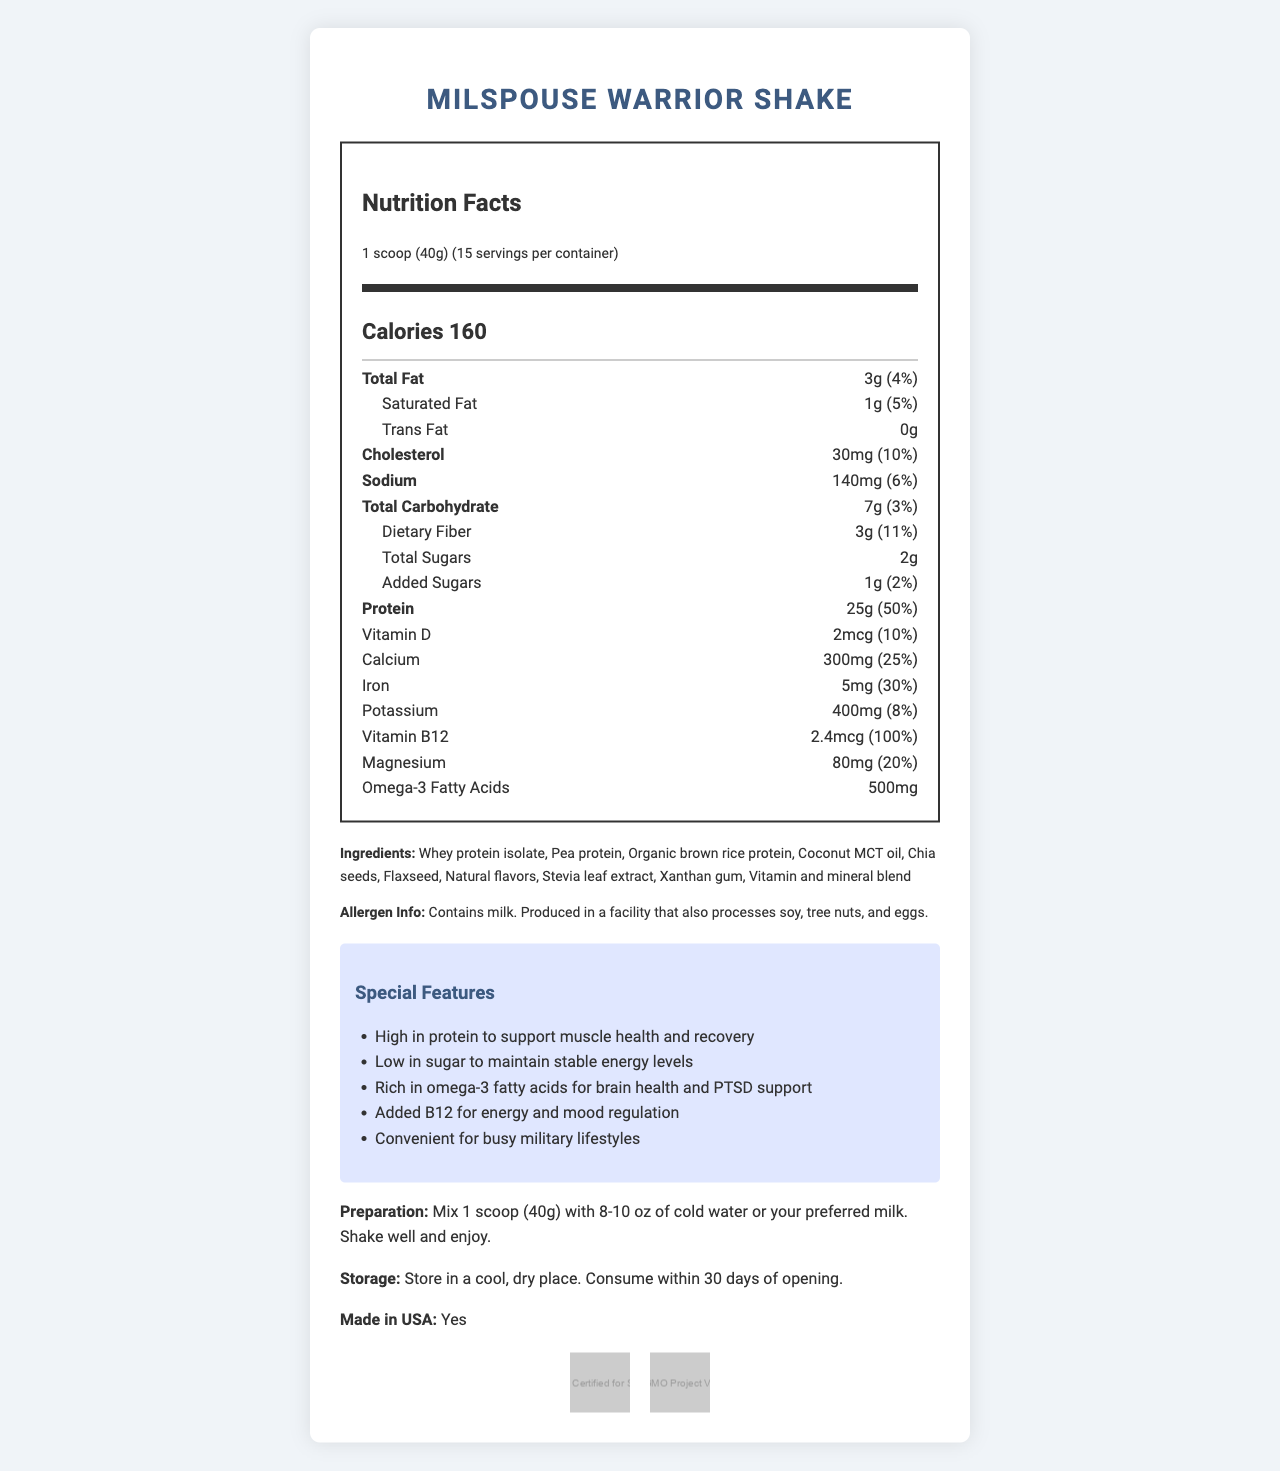what is the main source of protein in the MilSpouse Warrior Shake? The ingredients list indicates that "Whey protein isolate" is the first item, which means it is the main source of protein.
Answer: Whey protein isolate how many grams of total fat does each serving contain? The nutrition facts section of the document lists "Total Fat" as 3g per serving.
Answer: 3g what are the main features of the MilSpouse Warrior Shake? The document lists these features under the "Special Features" section.
Answer: High protein, Low sugar, Omega-3 fatty acids, Added B12, Convenience how many servings are there in one container? The document states "15 servings per container" in the nutrition facts section.
Answer: 15 what are the allergen warnings for this product? This information is explicitly stated under the "Allergen Info" section.
Answer: Contains milk. Produced in a facility that also processes soy, tree nuts, and eggs. how much vitamin D does each serving provide? The nutrition facts section shows that each serving provides 2mcg of vitamin D, which is 10% of the daily value.
Answer: 2mcg (10% DV) what is the amount of added sugars per serving? The nutrition facts indicate "Added Sugars" as 1g per serving.
Answer: 1g what are the certifications associated with the MilSpouse Warrior Shake? The document includes these certifications at the bottom of the page with visual icons.
Answer: NSF Certified for Sport, Non-GMO Project Verified which of the following is NOT an ingredient in the MilSpouse Warrior Shake? A. Chia seeds B. Coconut MCT oil C. Soy protein D. Stevia leaf extract The ingredients list does not include "Soy protein".
Answer: C. Soy protein what is the daily value percentage of protein per serving? A. 10% B. 20% C. 50% D. 100% The nutrition facts show that each serving provides 25g of protein, which is 50% of the daily value.
Answer: C. 50% is this product made in the USA? The document clearly states "Made in USA: Yes".
Answer: Yes describe the MilSpouse Warrior Shake nutrition facts and special features. The document provides detailed nutrition facts, including amounts of fat, cholesterol, carbohydrates, protein, and essential vitamins and minerals. It also lists several special features emphasizing the product's benefits for health and convenience.
Answer: The MilSpouse Warrior Shake is a meal replacement shake with high protein (25g per serving), low sugar (2g total sugars), various vitamins and minerals, and omega-3 fatty acids. It includes features such as protein for muscle recovery, low sugar for stable energy, omega-3 for brain health, added B12 for energy and mood regulation, and is convenient for busy military lifestyles. what is the recommended storage condition for this product? The storage instructions are clearly provided in the document.
Answer: Store in a cool, dry place. Consume within 30 days of opening. does the document mention the price of the MilSpouse Warrior Shake? The document includes detailed information about the nutrition facts, ingredients, and special features, but it does not mention the price.
Answer: Cannot be determined 